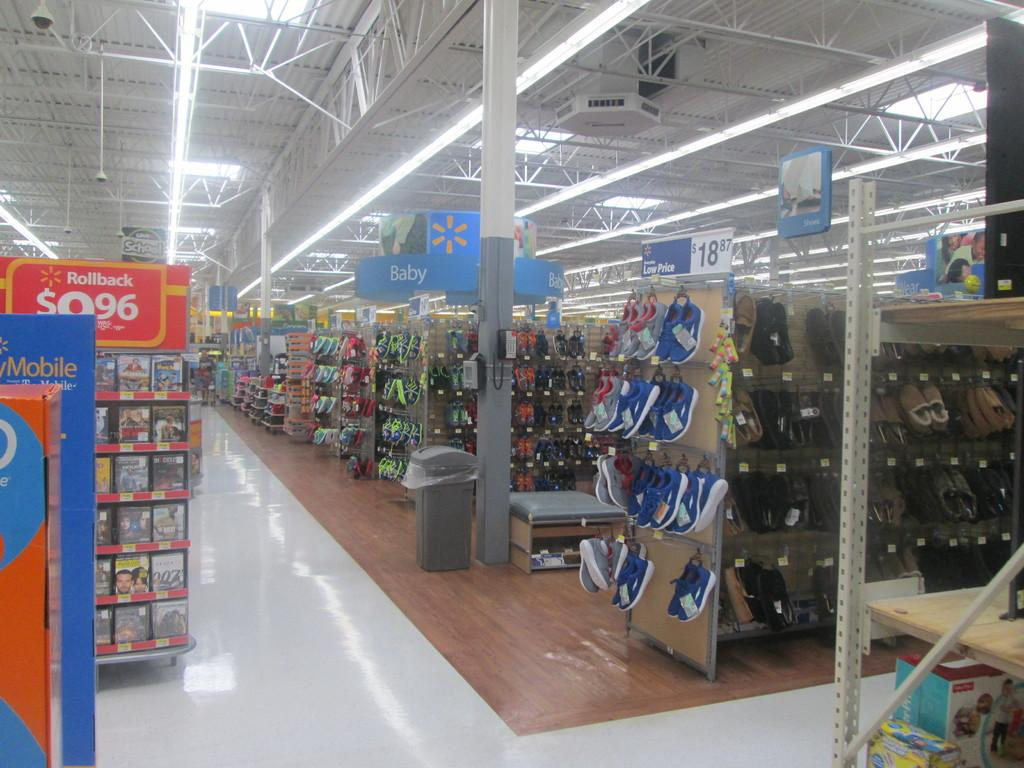<image>
Relay a brief, clear account of the picture shown. A shoe department in a Walmart and a sign that reads $9.96 Rollback. 